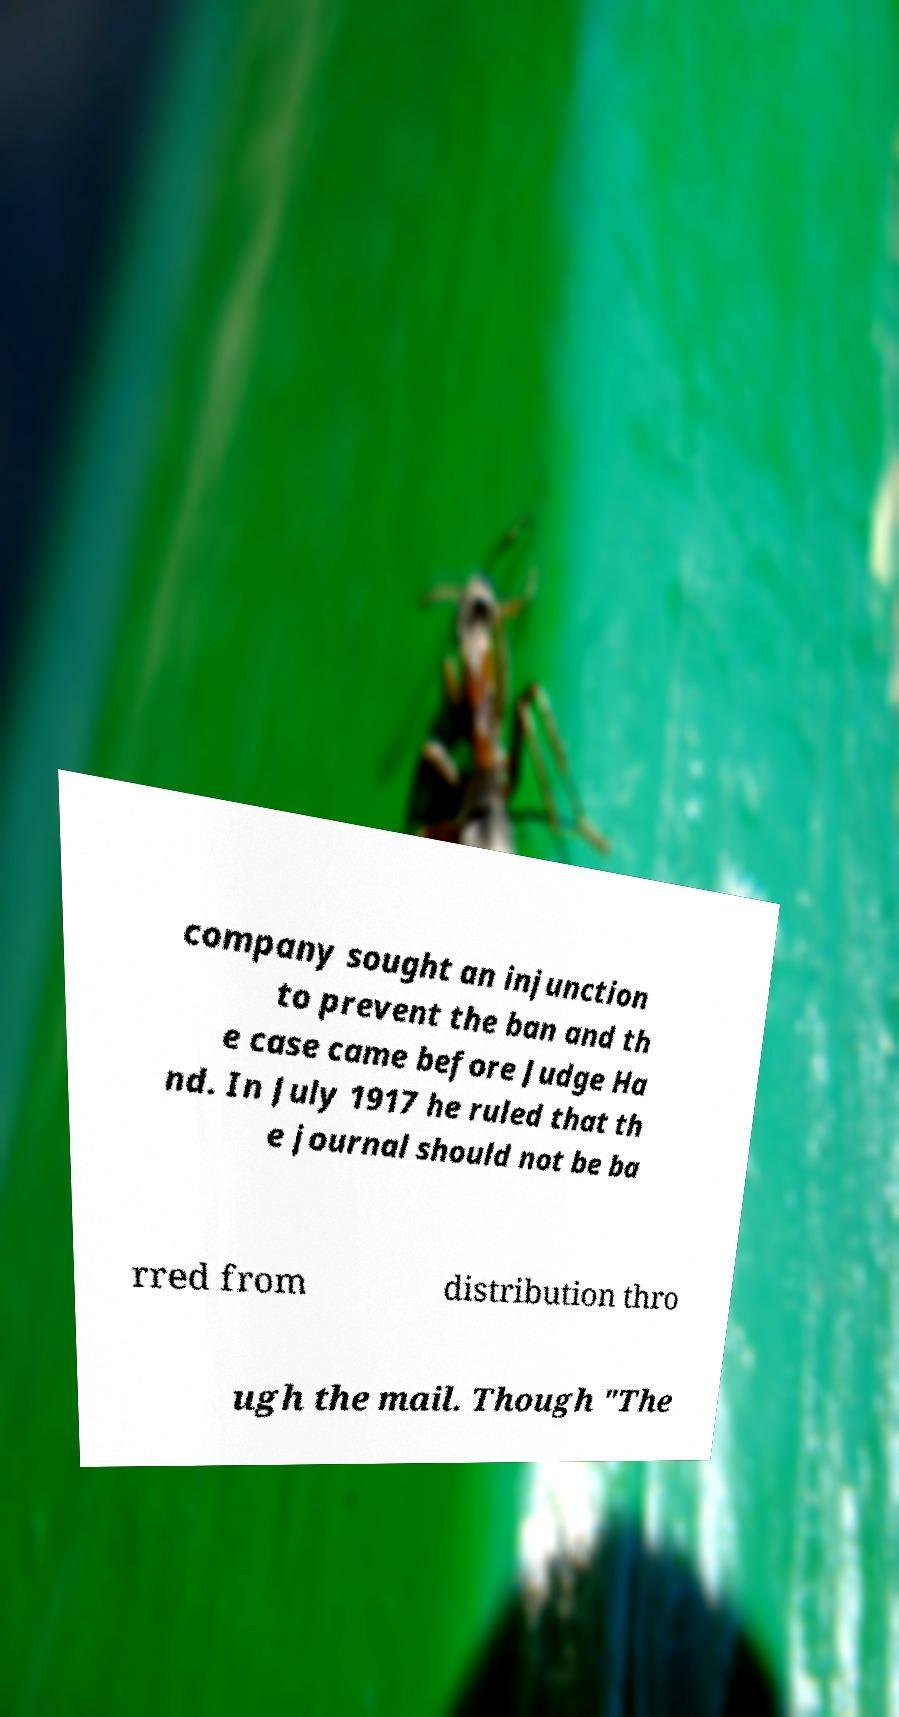Please read and relay the text visible in this image. What does it say? company sought an injunction to prevent the ban and th e case came before Judge Ha nd. In July 1917 he ruled that th e journal should not be ba rred from distribution thro ugh the mail. Though "The 